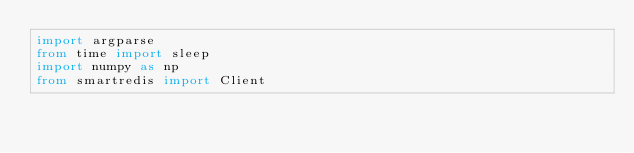Convert code to text. <code><loc_0><loc_0><loc_500><loc_500><_Python_>import argparse
from time import sleep
import numpy as np
from smartredis import Client
</code> 